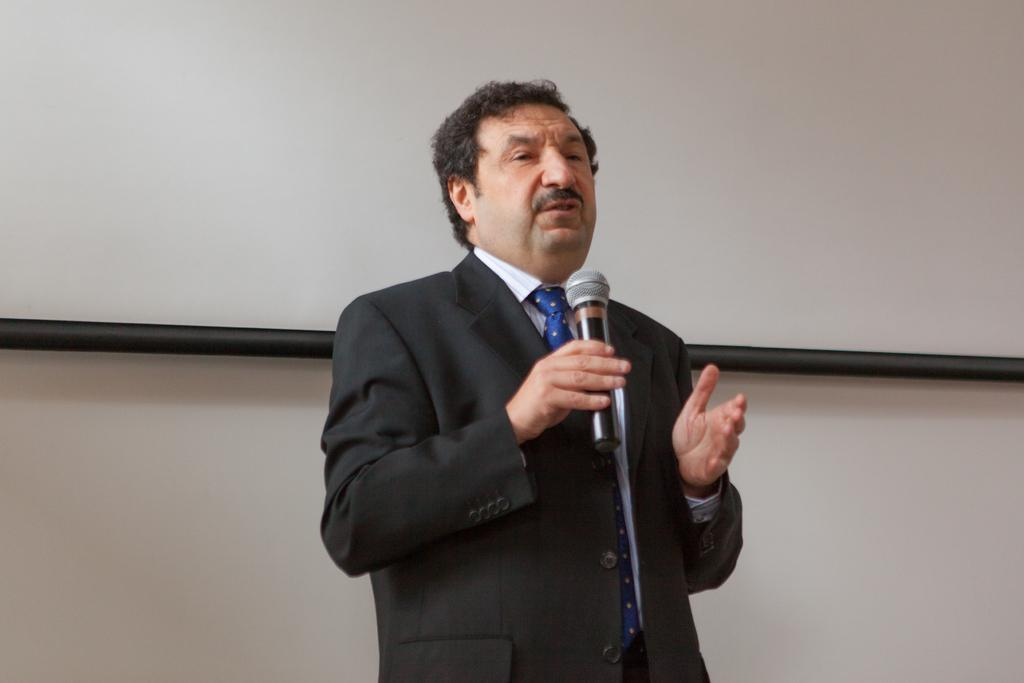What is the main subject of the image? The main subject of the image is a man. What is the man doing in the image? The man is standing and speaking into a microphone. What is the man holding in the image? The man is holding a microphone. What is the man wearing in the image? The man is wearing a coat and a tie. What type of scarecrow can be seen balancing on the man's interest in the image? There is no scarecrow or reference to balancing or interest in the image; it features a man holding a microphone and wearing a coat and tie. 